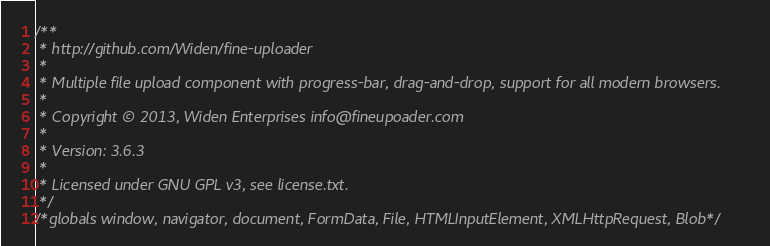Convert code to text. <code><loc_0><loc_0><loc_500><loc_500><_JavaScript_>/**
 * http://github.com/Widen/fine-uploader
 *
 * Multiple file upload component with progress-bar, drag-and-drop, support for all modern browsers.
 *
 * Copyright © 2013, Widen Enterprises info@fineupoader.com
 *
 * Version: 3.6.3
 *
 * Licensed under GNU GPL v3, see license.txt.
 */
/*globals window, navigator, document, FormData, File, HTMLInputElement, XMLHttpRequest, Blob*/</code> 